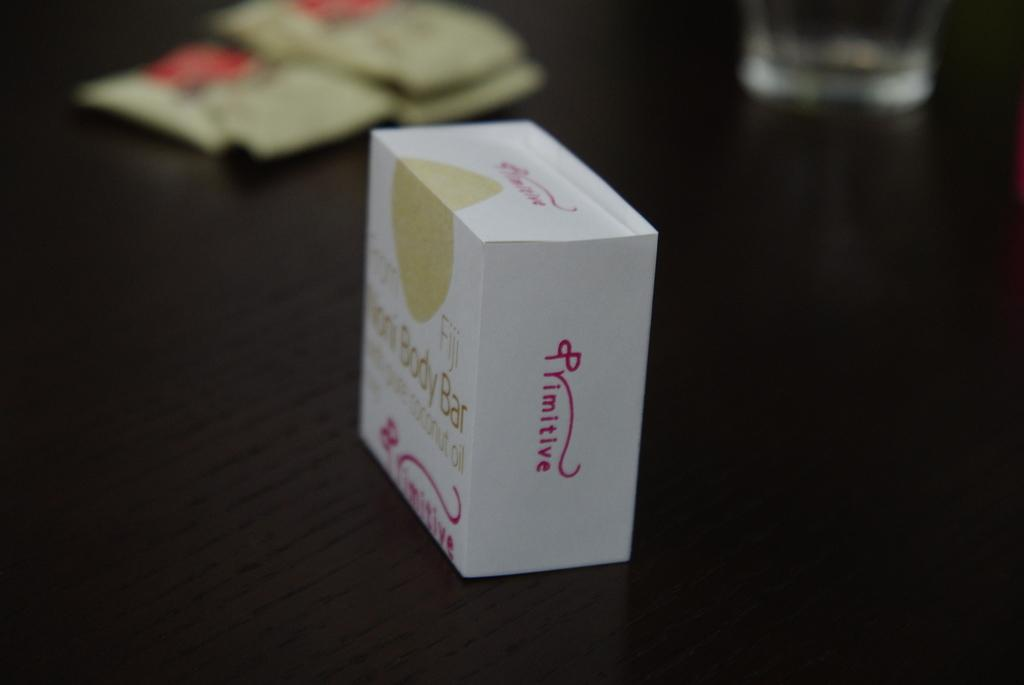Provide a one-sentence caption for the provided image. The body bar in the box contains coconut oil. 